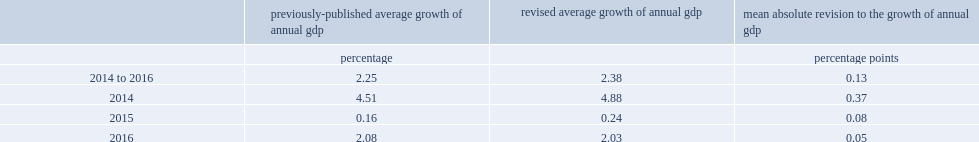What was the percentage of the mean absolute percentage point revision to the annual growth rate of nominal gdp for the period 2014 to 2016? 0.13. 